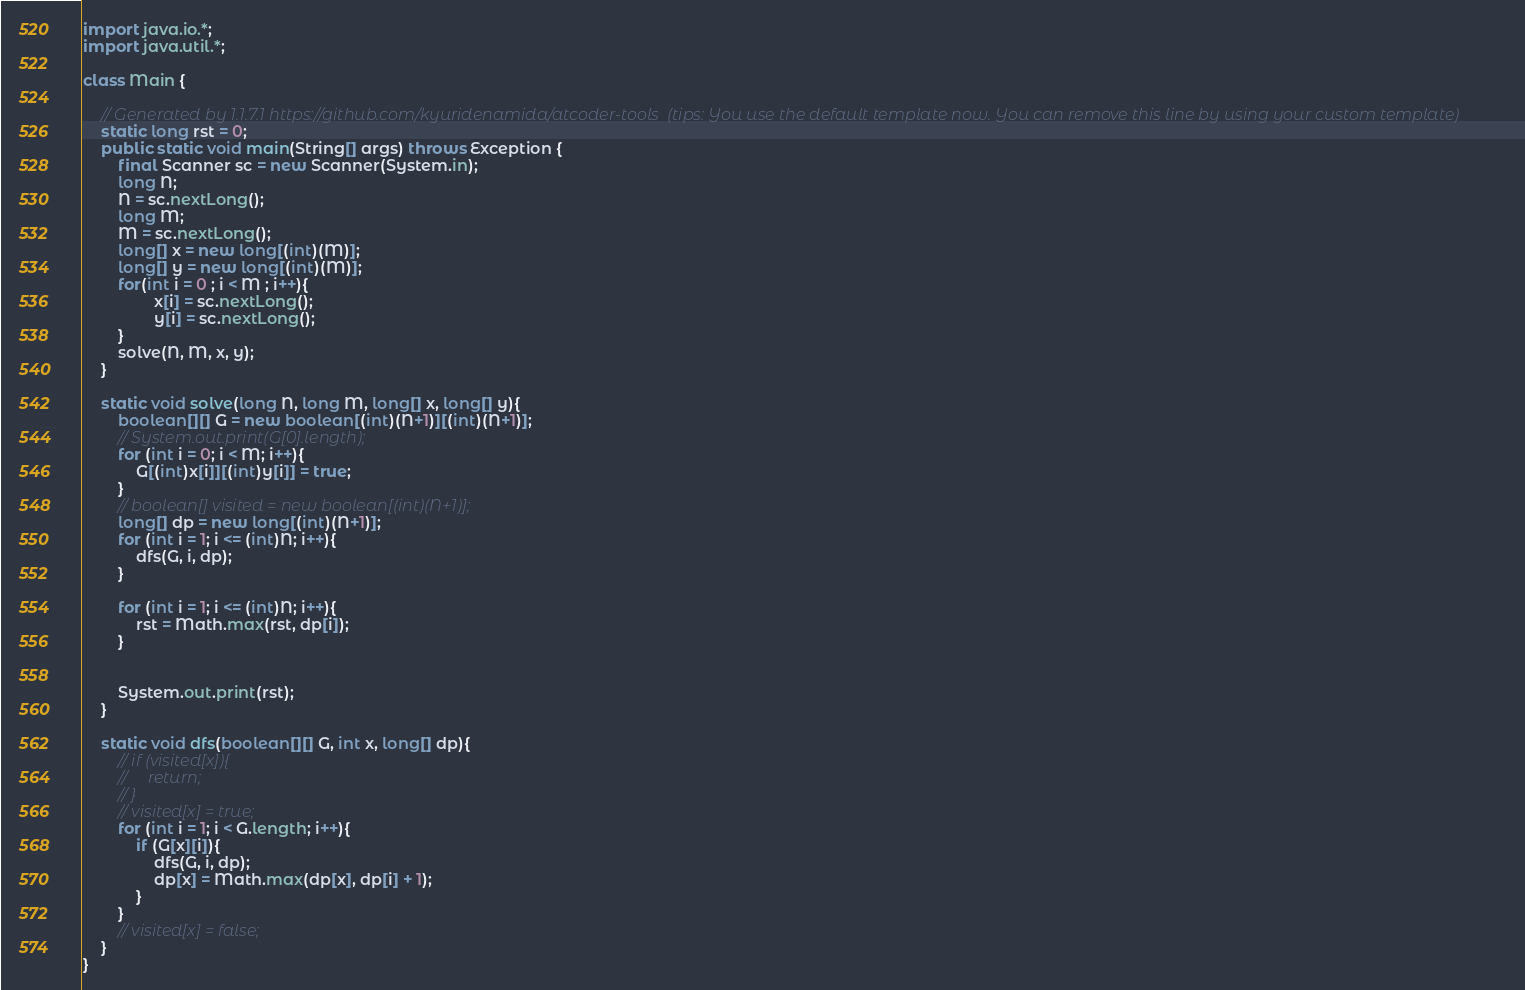<code> <loc_0><loc_0><loc_500><loc_500><_Java_>import java.io.*;
import java.util.*;

class Main {

    // Generated by 1.1.7.1 https://github.com/kyuridenamida/atcoder-tools  (tips: You use the default template now. You can remove this line by using your custom template)
    static long rst = 0;
    public static void main(String[] args) throws Exception {
        final Scanner sc = new Scanner(System.in);
        long N;
        N = sc.nextLong();
        long M;
        M = sc.nextLong();
        long[] x = new long[(int)(M)];
        long[] y = new long[(int)(M)];
        for(int i = 0 ; i < M ; i++){
                x[i] = sc.nextLong();
                y[i] = sc.nextLong();
        }
        solve(N, M, x, y);
    }

    static void solve(long N, long M, long[] x, long[] y){
        boolean[][] G = new boolean[(int)(N+1)][(int)(N+1)];
        // System.out.print(G[0].length);
        for (int i = 0; i < M; i++){
            G[(int)x[i]][(int)y[i]] = true;
        }
        // boolean[] visited = new boolean[(int)(N+1)];
        long[] dp = new long[(int)(N+1)];
        for (int i = 1; i <= (int)N; i++){
            dfs(G, i, dp);
        }

        for (int i = 1; i <= (int)N; i++){
            rst = Math.max(rst, dp[i]);
        }

        
        System.out.print(rst);
    }

    static void dfs(boolean[][] G, int x, long[] dp){
        // if (visited[x]){
        //     return;
        // }
        // visited[x] = true;
        for (int i = 1; i < G.length; i++){
            if (G[x][i]){
                dfs(G, i, dp);
                dp[x] = Math.max(dp[x], dp[i] + 1);
            }
        }
        // visited[x] = false;
    }
}
</code> 